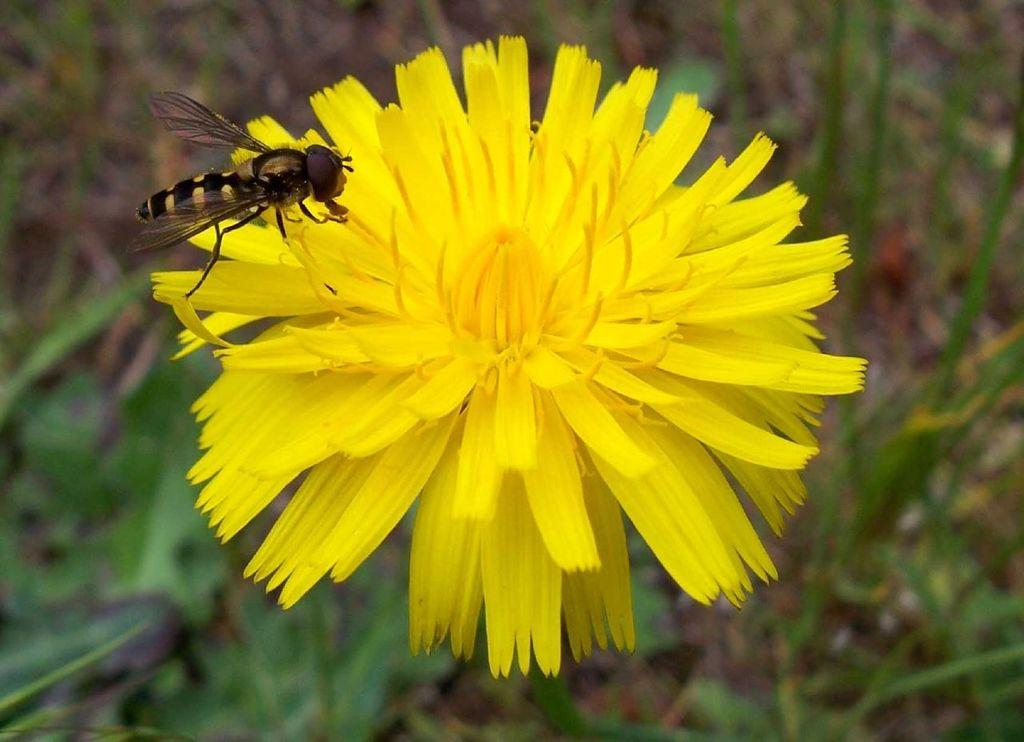What type of flower is in the image? There is a yellow flower in the image. Is there any other living organism interacting with the flower? Yes, there is a bee on the flower. What action is the animal performing in the image? There is no animal present in the image, only a bee, which is not considered an animal in this context. 